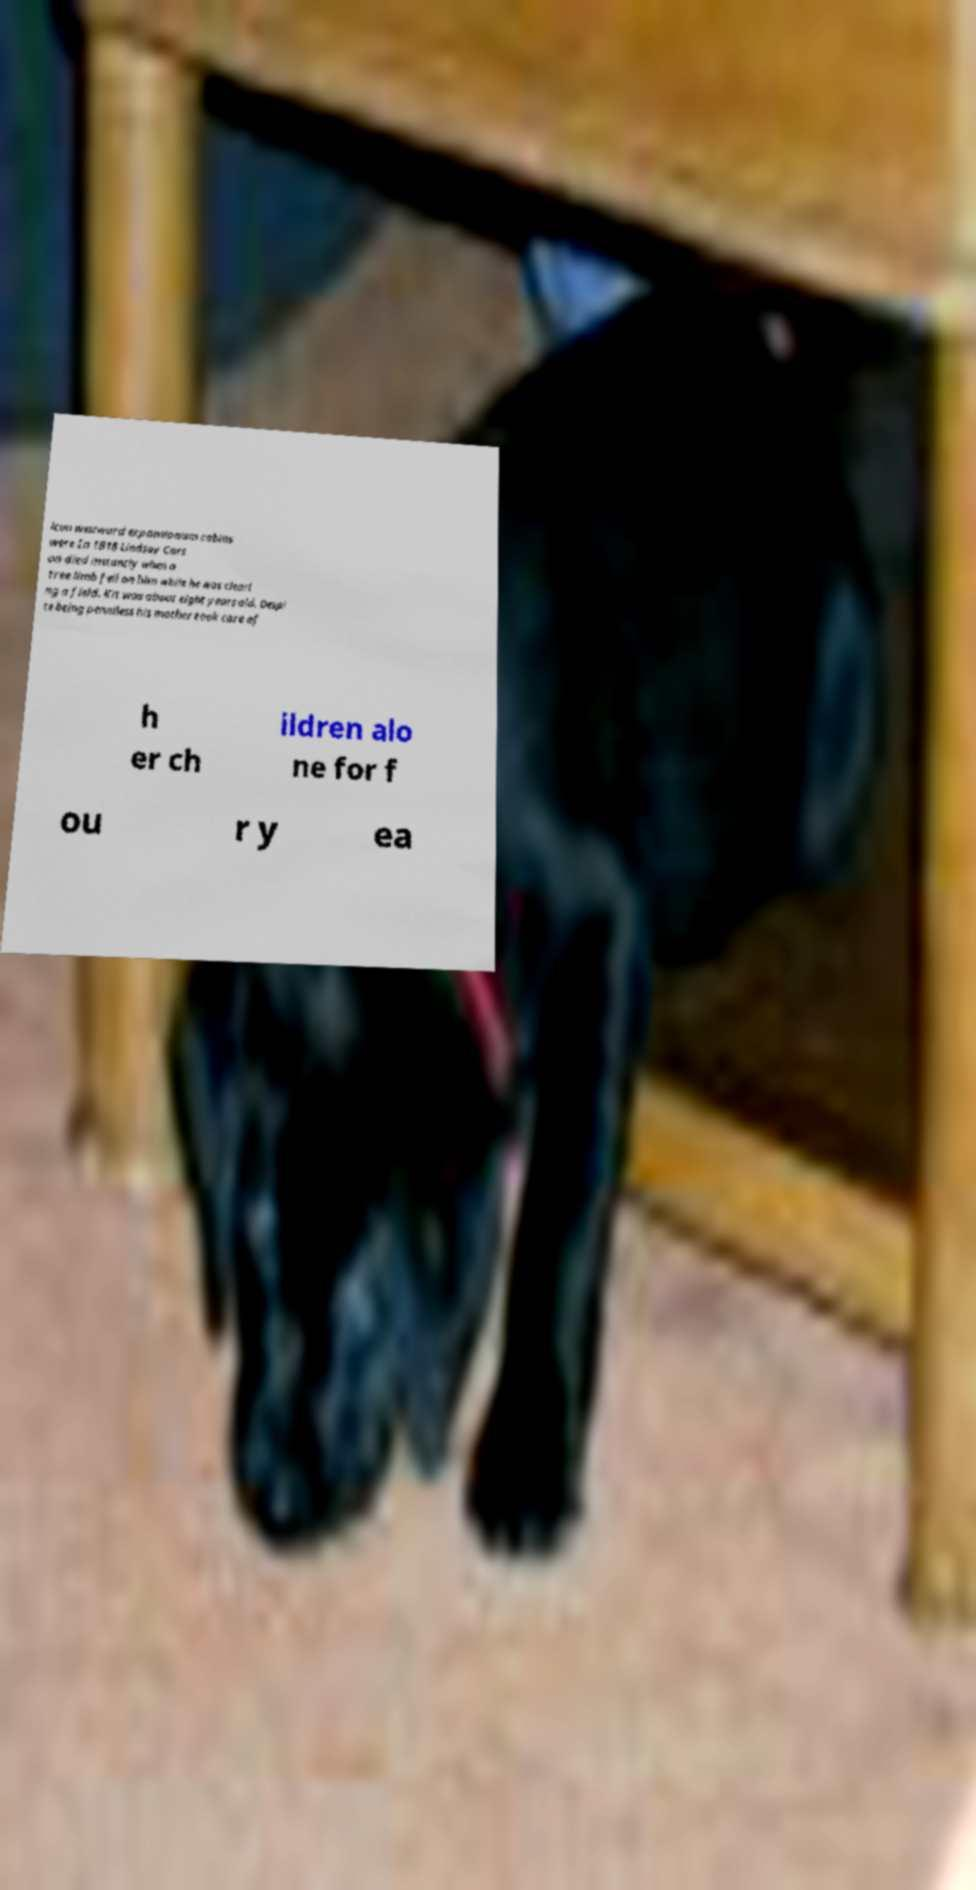For documentation purposes, I need the text within this image transcribed. Could you provide that? ican westward expansionism cabins were In 1818 Lindsay Cars on died instantly when a tree limb fell on him while he was cleari ng a field. Kit was about eight years old. Despi te being penniless his mother took care of h er ch ildren alo ne for f ou r y ea 